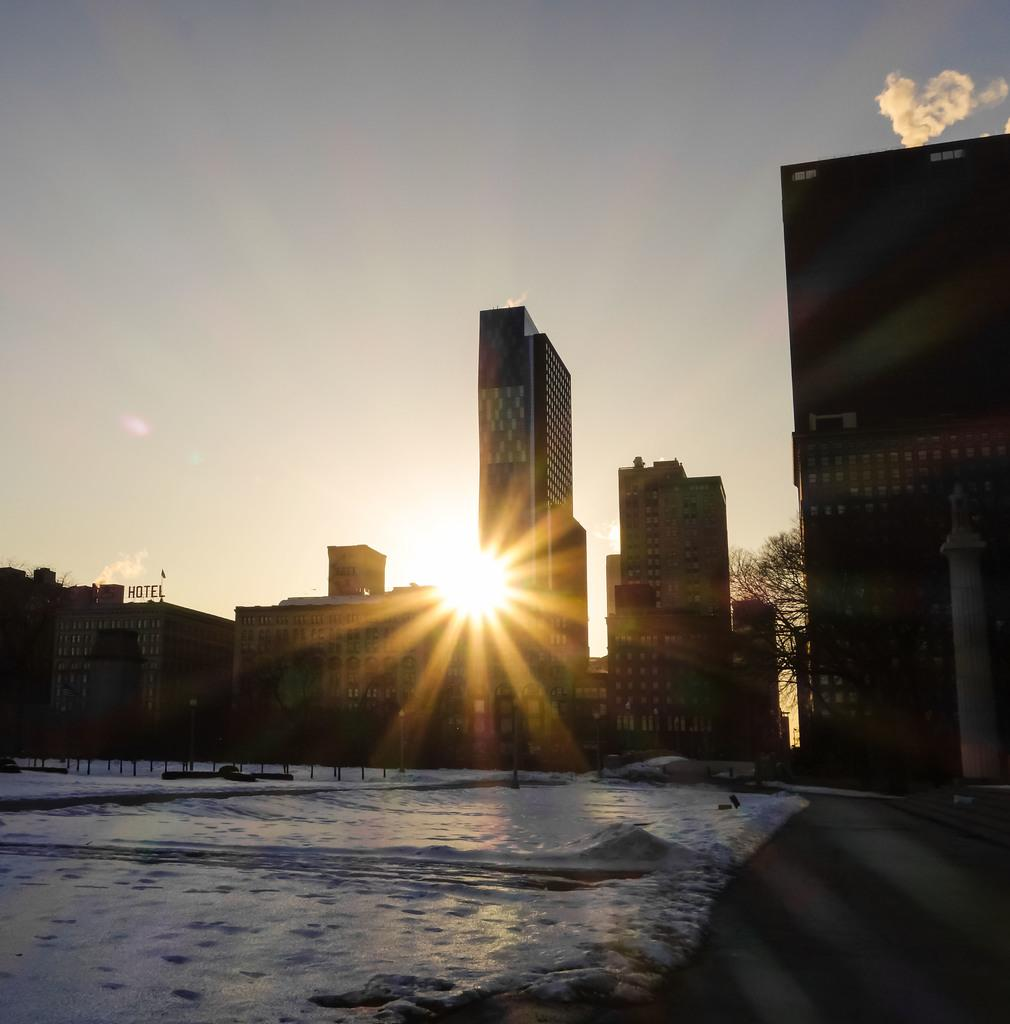What type of structures are present in the image? The image contains buildings. What is covering the ground in the image? There is snow at the bottom of the image. What can be seen in the sky in the background of the image? The sun is visible in the sky in the background of the image. How many seats are available for people to sit on in the image? There is no information about seats in the image; it contains buildings, snow, and the sun. 